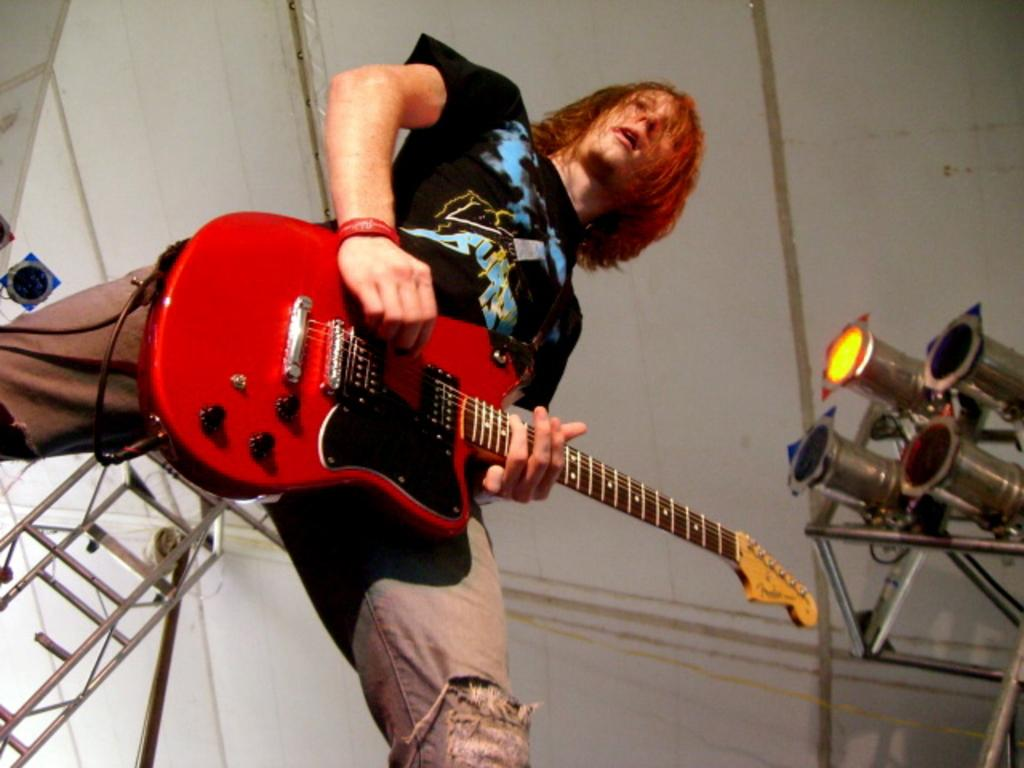What is the person in the image doing? The person is playing a guitar. What objects can be seen in the image besides the person? There are rods and lights visible in the image. What is the color of the background in the image? The background of the image is a white color surface. What type of drug is the person receiving as a reward in the image? There is no drug or reward present in the image; it features a person playing a guitar with rods and lights in the background. 